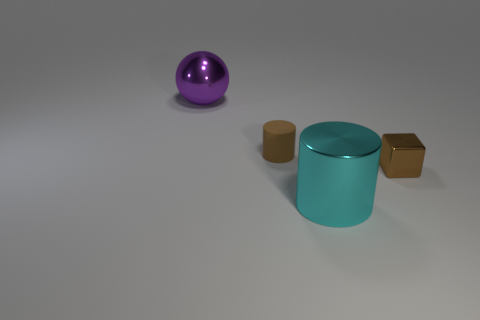Are there the same number of large purple metallic balls that are on the right side of the big purple shiny thing and large red metallic blocks? Indeed, there is an equal number of large purple metallic balls and large red metallic blocks in the image. To be specific, there is one large purple metallic ball on the right side of a big, possibly shiny, object which appears to be a cylinder rather than 'thing', and there is one large red metallic block in the scene, thus maintaining the balance. 